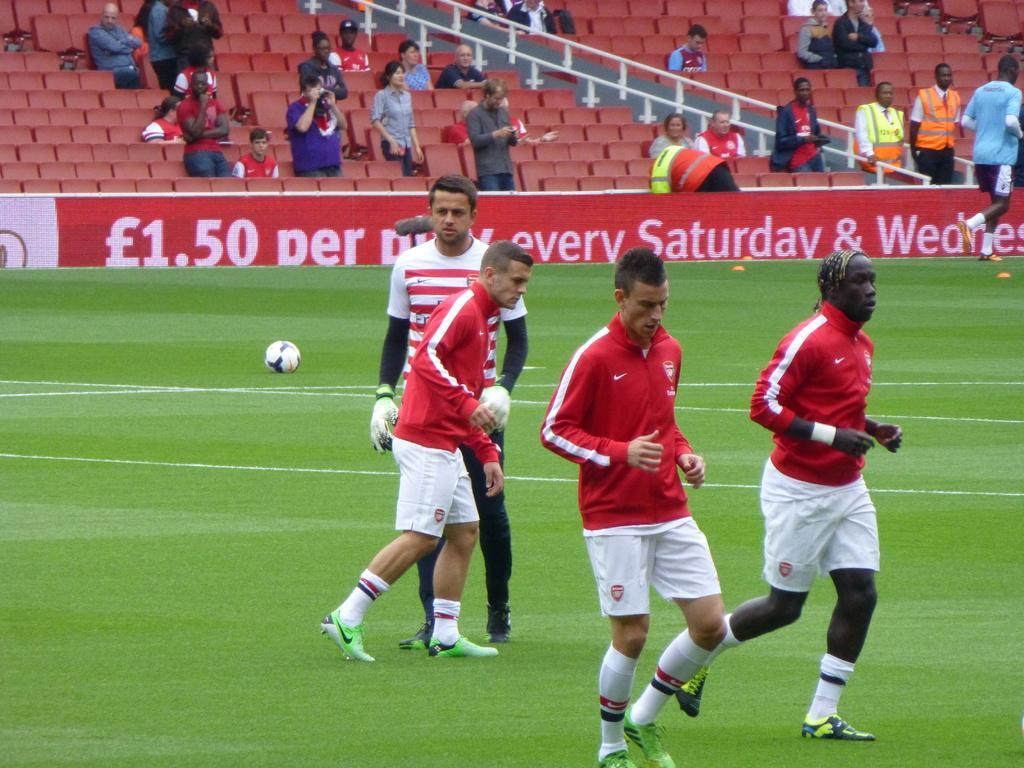<image>
Offer a succinct explanation of the picture presented. Soccer players in front of an ad which says Saturday on it. 